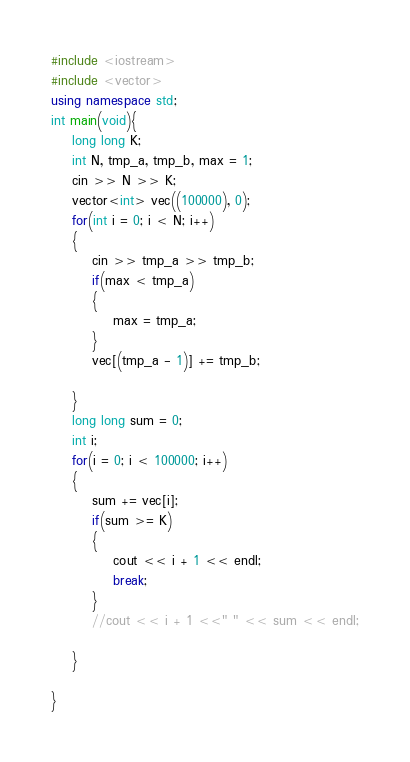Convert code to text. <code><loc_0><loc_0><loc_500><loc_500><_C++_>#include <iostream>
#include <vector>
using namespace std;
int main(void){
    long long K;
    int N, tmp_a, tmp_b, max = 1;
    cin >> N >> K;
    vector<int> vec((100000), 0);
    for(int i = 0; i < N; i++)
    {
        cin >> tmp_a >> tmp_b;
        if(max < tmp_a)
        {
            max = tmp_a;
        }
        vec[(tmp_a - 1)] += tmp_b;
 
    }
    long long sum = 0;
    int i;
    for(i = 0; i < 100000; i++)
    {
        sum += vec[i];
        if(sum >= K)
        {
            cout << i + 1 << endl;
            break;
        }
        //cout << i + 1 <<" " << sum << endl;

    }
    
}</code> 